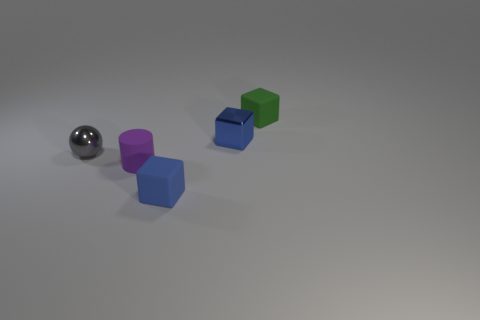Subtract all tiny rubber cubes. How many cubes are left? 1 Subtract all green spheres. How many blue cubes are left? 2 Add 3 shiny balls. How many objects exist? 8 Subtract all brown blocks. Subtract all red spheres. How many blocks are left? 3 Subtract all blocks. How many objects are left? 2 Subtract all rubber cylinders. Subtract all small cyan rubber balls. How many objects are left? 4 Add 5 metallic things. How many metallic things are left? 7 Add 2 yellow blocks. How many yellow blocks exist? 2 Subtract 0 red cylinders. How many objects are left? 5 